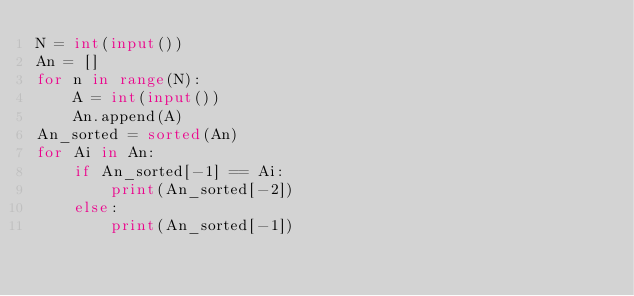<code> <loc_0><loc_0><loc_500><loc_500><_Python_>N = int(input())
An = []
for n in range(N):
    A = int(input())
    An.append(A)
An_sorted = sorted(An)
for Ai in An:
    if An_sorted[-1] == Ai:
        print(An_sorted[-2])
    else:
        print(An_sorted[-1])
</code> 